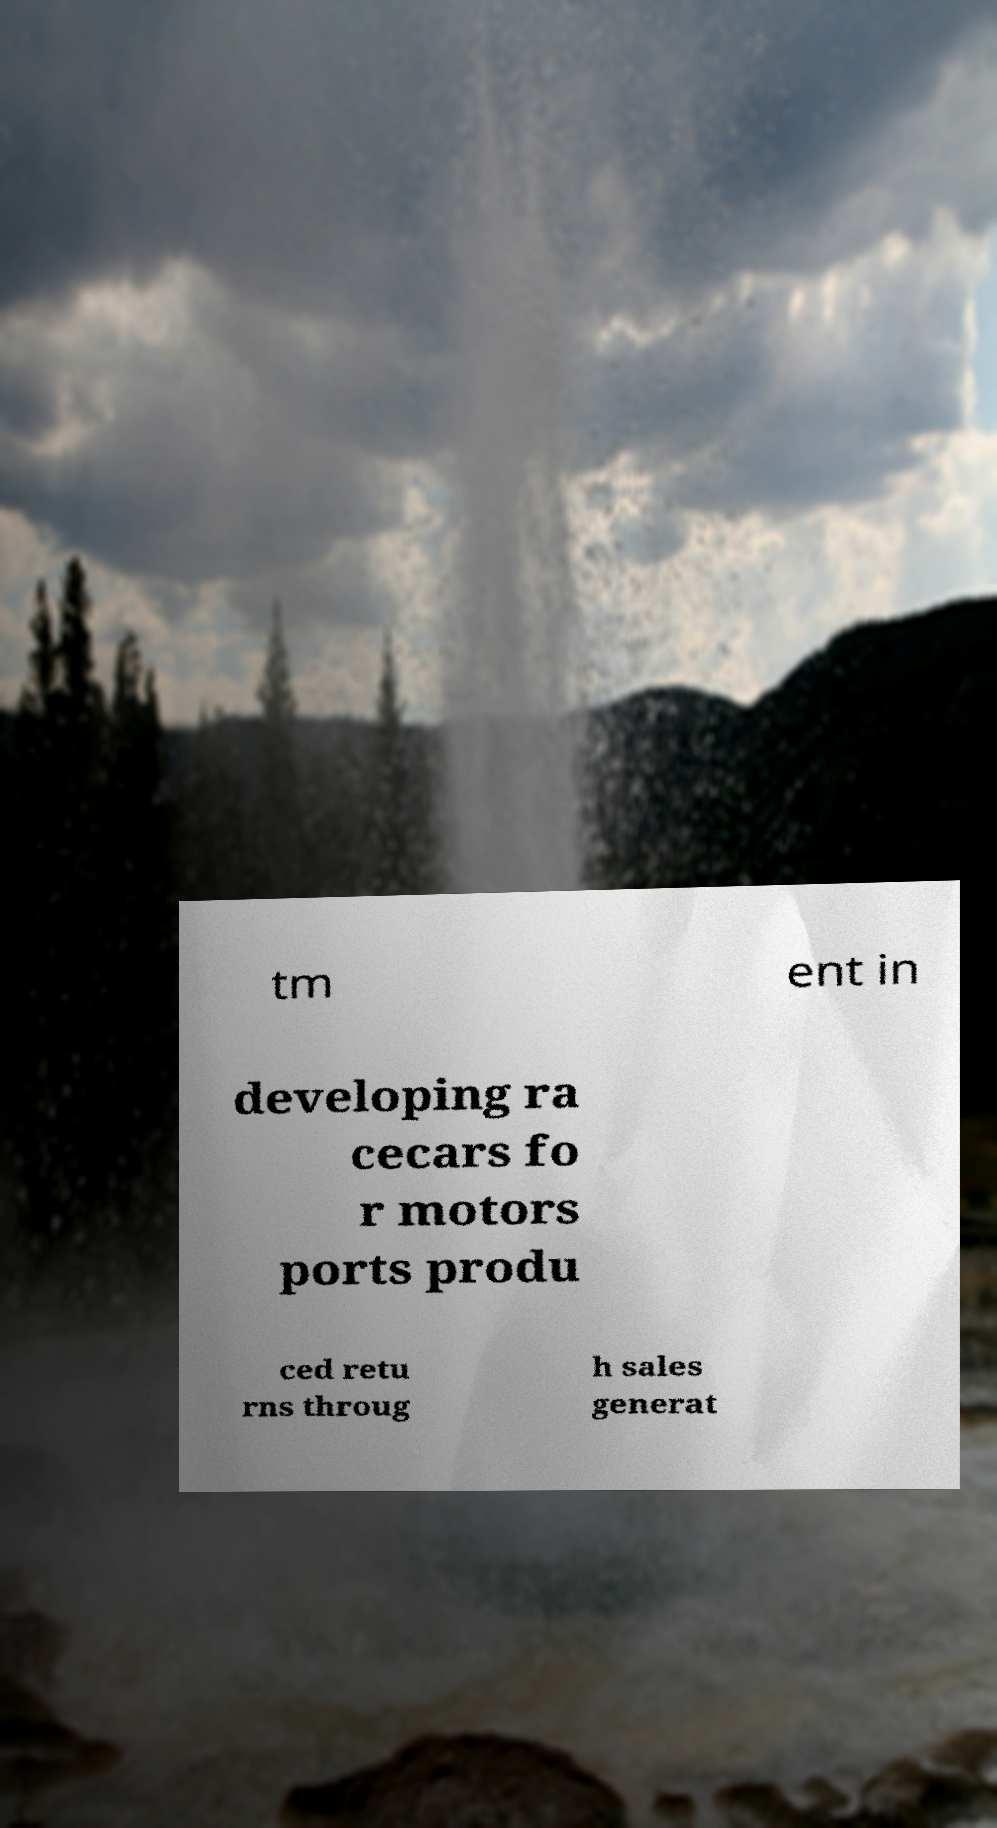Can you read and provide the text displayed in the image?This photo seems to have some interesting text. Can you extract and type it out for me? tm ent in developing ra cecars fo r motors ports produ ced retu rns throug h sales generat 